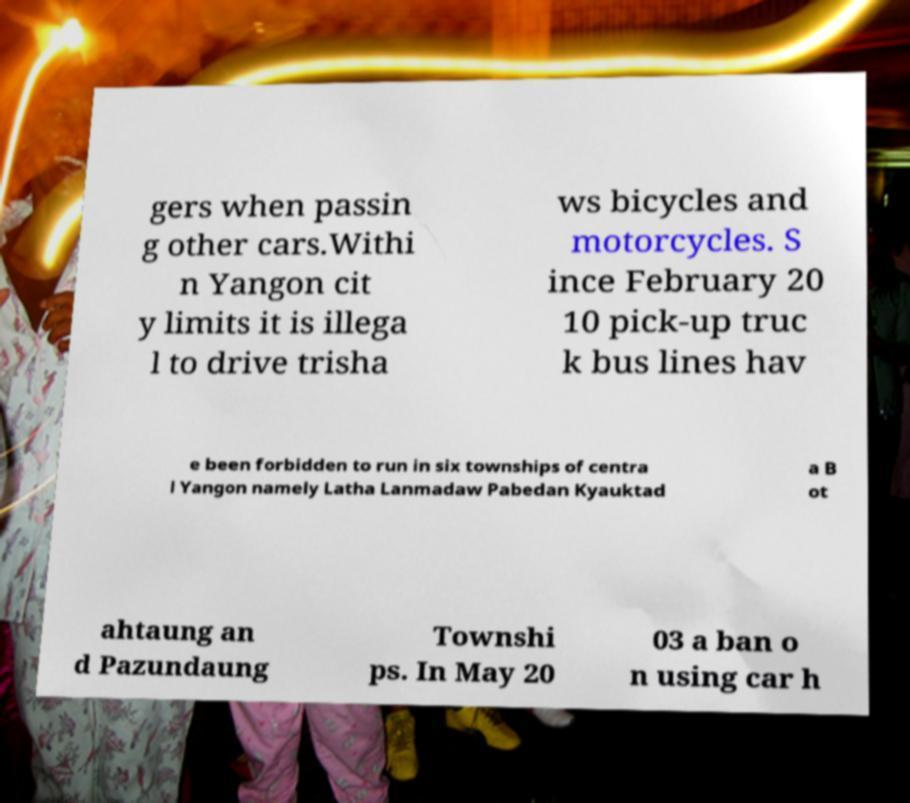There's text embedded in this image that I need extracted. Can you transcribe it verbatim? gers when passin g other cars.Withi n Yangon cit y limits it is illega l to drive trisha ws bicycles and motorcycles. S ince February 20 10 pick-up truc k bus lines hav e been forbidden to run in six townships of centra l Yangon namely Latha Lanmadaw Pabedan Kyauktad a B ot ahtaung an d Pazundaung Townshi ps. In May 20 03 a ban o n using car h 